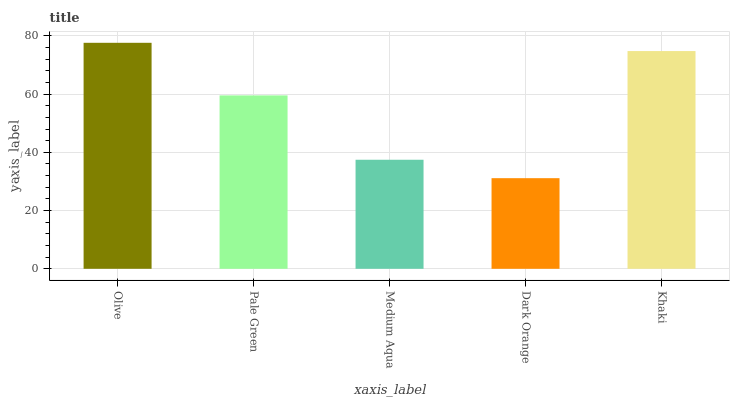Is Dark Orange the minimum?
Answer yes or no. Yes. Is Olive the maximum?
Answer yes or no. Yes. Is Pale Green the minimum?
Answer yes or no. No. Is Pale Green the maximum?
Answer yes or no. No. Is Olive greater than Pale Green?
Answer yes or no. Yes. Is Pale Green less than Olive?
Answer yes or no. Yes. Is Pale Green greater than Olive?
Answer yes or no. No. Is Olive less than Pale Green?
Answer yes or no. No. Is Pale Green the high median?
Answer yes or no. Yes. Is Pale Green the low median?
Answer yes or no. Yes. Is Dark Orange the high median?
Answer yes or no. No. Is Medium Aqua the low median?
Answer yes or no. No. 